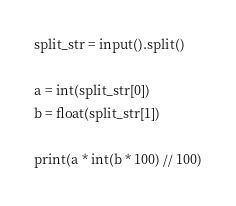<code> <loc_0><loc_0><loc_500><loc_500><_Python_>split_str = input().split()

a = int(split_str[0])
b = float(split_str[1])

print(a * int(b * 100) // 100)
</code> 